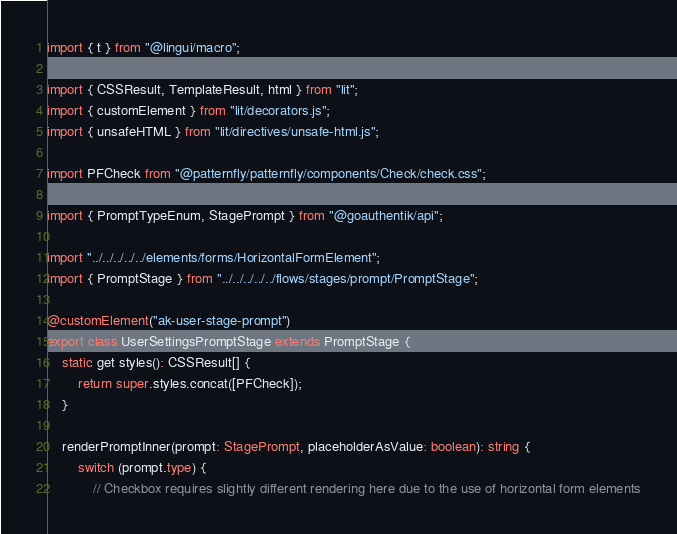Convert code to text. <code><loc_0><loc_0><loc_500><loc_500><_TypeScript_>import { t } from "@lingui/macro";

import { CSSResult, TemplateResult, html } from "lit";
import { customElement } from "lit/decorators.js";
import { unsafeHTML } from "lit/directives/unsafe-html.js";

import PFCheck from "@patternfly/patternfly/components/Check/check.css";

import { PromptTypeEnum, StagePrompt } from "@goauthentik/api";

import "../../../../../elements/forms/HorizontalFormElement";
import { PromptStage } from "../../../../../flows/stages/prompt/PromptStage";

@customElement("ak-user-stage-prompt")
export class UserSettingsPromptStage extends PromptStage {
    static get styles(): CSSResult[] {
        return super.styles.concat([PFCheck]);
    }

    renderPromptInner(prompt: StagePrompt, placeholderAsValue: boolean): string {
        switch (prompt.type) {
            // Checkbox requires slightly different rendering here due to the use of horizontal form elements</code> 